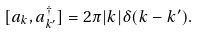Convert formula to latex. <formula><loc_0><loc_0><loc_500><loc_500>[ a _ { k } , a ^ { \dagger } _ { k ^ { \prime } } ] = 2 \pi | k | \delta ( k - k ^ { \prime } ) .</formula> 